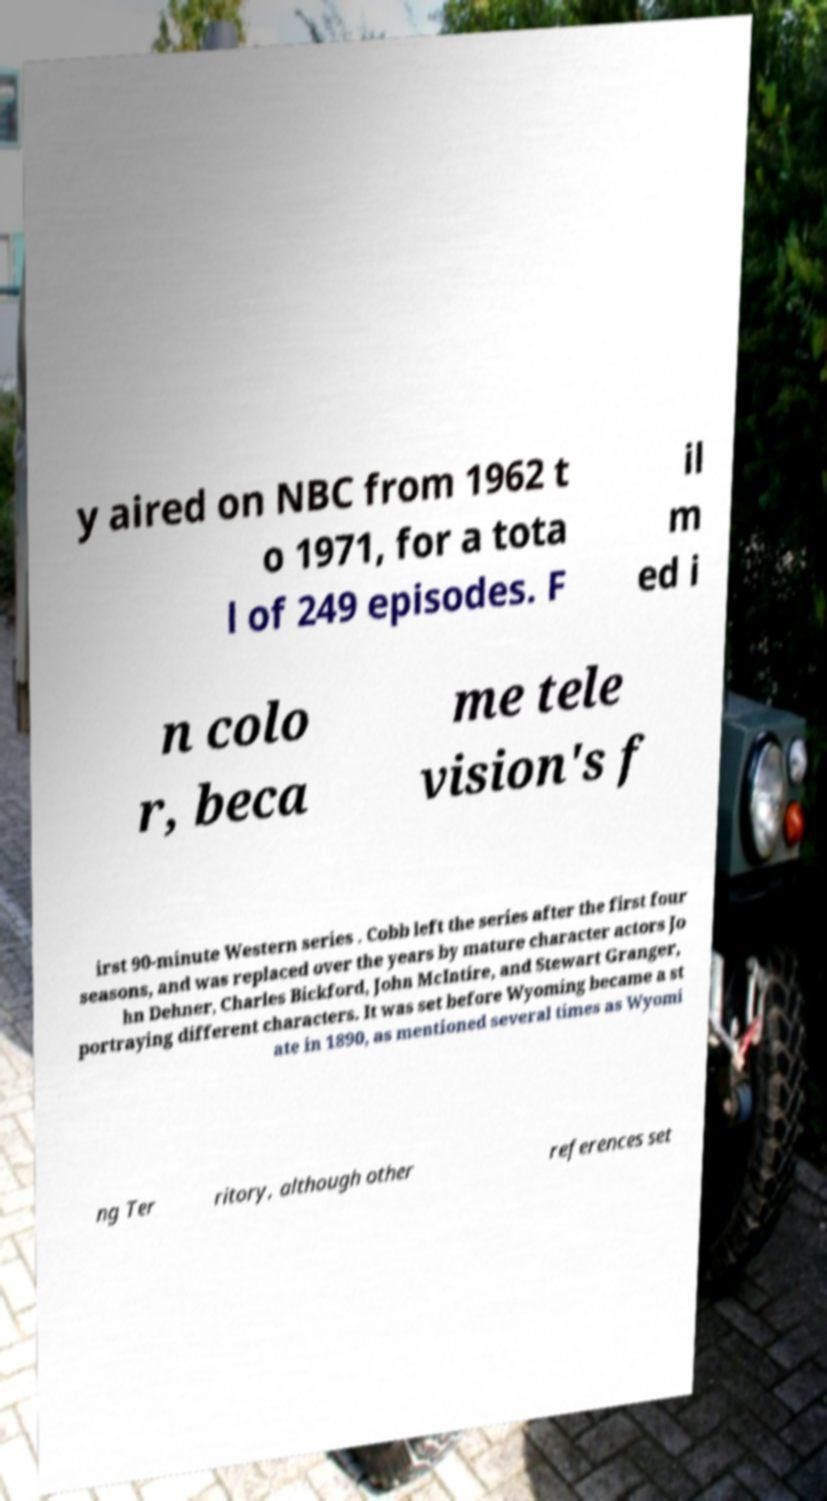Could you extract and type out the text from this image? y aired on NBC from 1962 t o 1971, for a tota l of 249 episodes. F il m ed i n colo r, beca me tele vision's f irst 90-minute Western series . Cobb left the series after the first four seasons, and was replaced over the years by mature character actors Jo hn Dehner, Charles Bickford, John McIntire, and Stewart Granger, portraying different characters. It was set before Wyoming became a st ate in 1890, as mentioned several times as Wyomi ng Ter ritory, although other references set 